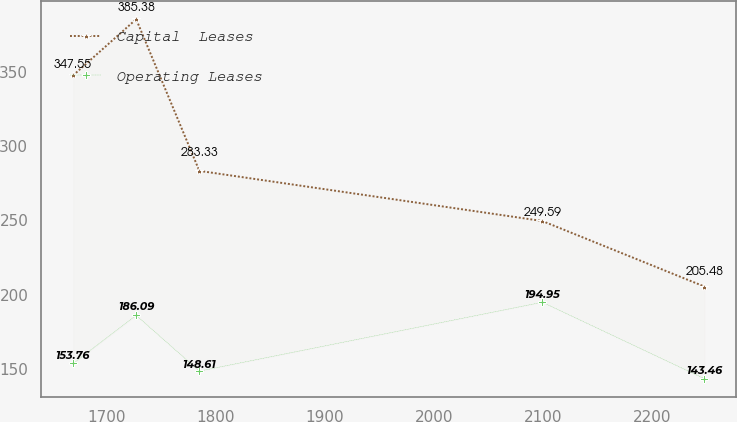<chart> <loc_0><loc_0><loc_500><loc_500><line_chart><ecel><fcel>Capital  Leases<fcel>Operating Leases<nl><fcel>1669.33<fcel>347.55<fcel>153.76<nl><fcel>1727.2<fcel>385.38<fcel>186.09<nl><fcel>1785.07<fcel>283.33<fcel>148.61<nl><fcel>2099.39<fcel>249.59<fcel>194.95<nl><fcel>2247.99<fcel>205.48<fcel>143.46<nl></chart> 